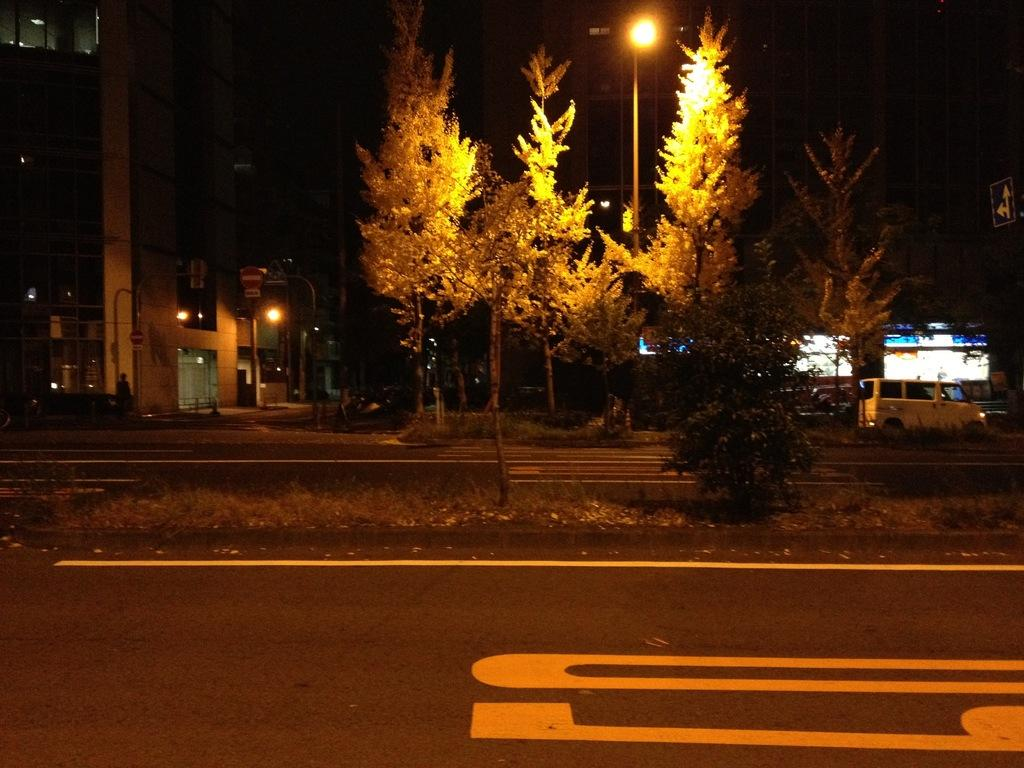What is at the bottom of the image? There is a road at the bottom of the image. What is on the road? There is a car on the road. What type of vegetation is present in the image? There are trees in the image. What can be seen in the background of the image? There are poles with street lights and buildings in the background. Can you see a lead snake slithering on the road in the image? No, there is no snake, lead, or any slithering activity present in the image. 